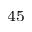Convert formula to latex. <formula><loc_0><loc_0><loc_500><loc_500>^ { 4 5 }</formula> 